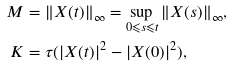Convert formula to latex. <formula><loc_0><loc_0><loc_500><loc_500>M & = \| X ( t ) \| _ { \infty } = \sup _ { 0 \leqslant s \leqslant t } \| X ( s ) \| _ { \infty } , \\ K & = \tau ( | X ( t ) | ^ { 2 } - | X ( 0 ) | ^ { 2 } ) ,</formula> 